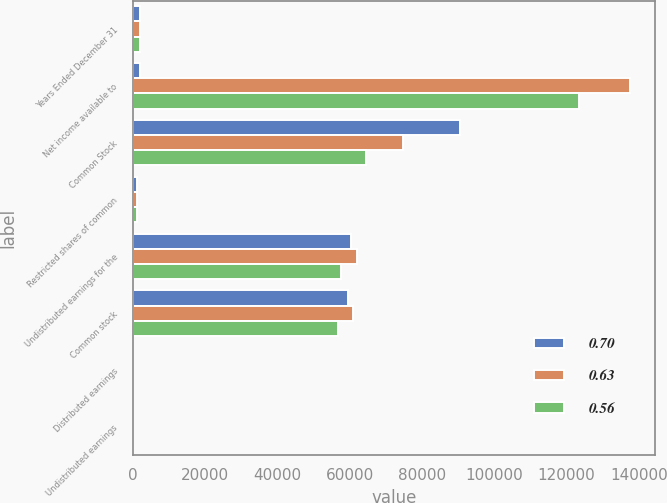Convert chart to OTSL. <chart><loc_0><loc_0><loc_500><loc_500><stacked_bar_chart><ecel><fcel>Years Ended December 31<fcel>Net income available to<fcel>Common Stock<fcel>Restricted shares of common<fcel>Undistributed earnings for the<fcel>Common stock<fcel>Distributed earnings<fcel>Undistributed earnings<nl><fcel>0.7<fcel>2015<fcel>2015<fcel>90631<fcel>1124<fcel>60394<fcel>59611<fcel>0.42<fcel>0.28<nl><fcel>0.63<fcel>2014<fcel>137664<fcel>74704<fcel>1046<fcel>61914<fcel>61001<fcel>0.35<fcel>0.28<nl><fcel>0.56<fcel>2013<fcel>123330<fcel>64571<fcel>1087<fcel>57672<fcel>56663<fcel>0.3<fcel>0.26<nl></chart> 